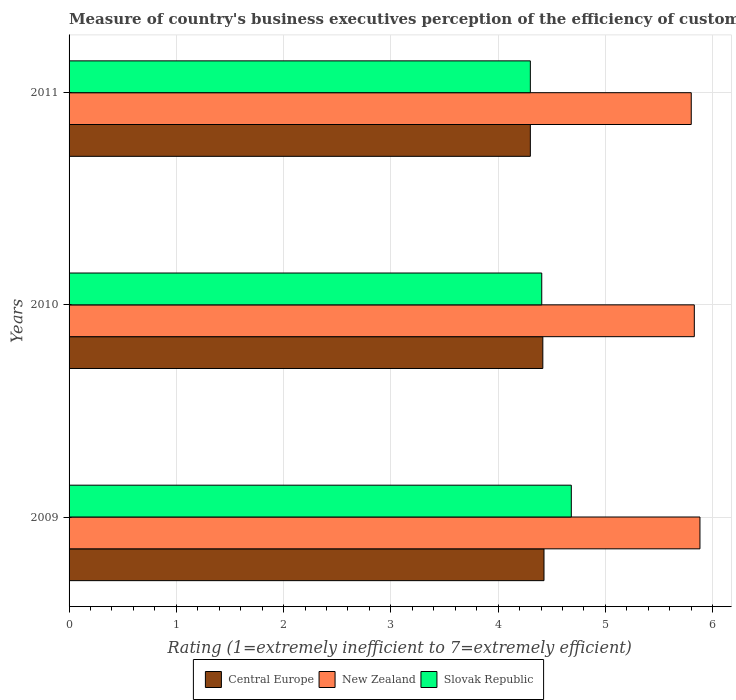How many groups of bars are there?
Give a very brief answer. 3. Are the number of bars per tick equal to the number of legend labels?
Your answer should be compact. Yes. Are the number of bars on each tick of the Y-axis equal?
Provide a succinct answer. Yes. How many bars are there on the 2nd tick from the top?
Your response must be concise. 3. How many bars are there on the 1st tick from the bottom?
Provide a short and direct response. 3. What is the label of the 1st group of bars from the top?
Ensure brevity in your answer.  2011. Across all years, what is the maximum rating of the efficiency of customs procedure in Slovak Republic?
Give a very brief answer. 4.68. In which year was the rating of the efficiency of customs procedure in Central Europe maximum?
Provide a short and direct response. 2009. In which year was the rating of the efficiency of customs procedure in New Zealand minimum?
Provide a succinct answer. 2011. What is the total rating of the efficiency of customs procedure in Slovak Republic in the graph?
Give a very brief answer. 13.39. What is the difference between the rating of the efficiency of customs procedure in New Zealand in 2010 and that in 2011?
Your response must be concise. 0.03. What is the difference between the rating of the efficiency of customs procedure in Central Europe in 2009 and the rating of the efficiency of customs procedure in Slovak Republic in 2011?
Provide a short and direct response. 0.13. What is the average rating of the efficiency of customs procedure in Slovak Republic per year?
Your response must be concise. 4.46. In the year 2011, what is the difference between the rating of the efficiency of customs procedure in New Zealand and rating of the efficiency of customs procedure in Central Europe?
Provide a succinct answer. 1.5. In how many years, is the rating of the efficiency of customs procedure in Slovak Republic greater than 5 ?
Your answer should be compact. 0. What is the ratio of the rating of the efficiency of customs procedure in Slovak Republic in 2010 to that in 2011?
Provide a succinct answer. 1.02. Is the rating of the efficiency of customs procedure in Central Europe in 2010 less than that in 2011?
Give a very brief answer. No. Is the difference between the rating of the efficiency of customs procedure in New Zealand in 2009 and 2011 greater than the difference between the rating of the efficiency of customs procedure in Central Europe in 2009 and 2011?
Give a very brief answer. No. What is the difference between the highest and the second highest rating of the efficiency of customs procedure in New Zealand?
Your response must be concise. 0.05. What is the difference between the highest and the lowest rating of the efficiency of customs procedure in Central Europe?
Make the answer very short. 0.13. Is the sum of the rating of the efficiency of customs procedure in Slovak Republic in 2010 and 2011 greater than the maximum rating of the efficiency of customs procedure in Central Europe across all years?
Make the answer very short. Yes. What does the 1st bar from the top in 2011 represents?
Keep it short and to the point. Slovak Republic. What does the 1st bar from the bottom in 2010 represents?
Provide a succinct answer. Central Europe. Is it the case that in every year, the sum of the rating of the efficiency of customs procedure in Central Europe and rating of the efficiency of customs procedure in Slovak Republic is greater than the rating of the efficiency of customs procedure in New Zealand?
Provide a succinct answer. Yes. Are all the bars in the graph horizontal?
Your answer should be compact. Yes. How many years are there in the graph?
Give a very brief answer. 3. Are the values on the major ticks of X-axis written in scientific E-notation?
Offer a terse response. No. Where does the legend appear in the graph?
Offer a very short reply. Bottom center. What is the title of the graph?
Offer a terse response. Measure of country's business executives perception of the efficiency of customs procedures. What is the label or title of the X-axis?
Ensure brevity in your answer.  Rating (1=extremely inefficient to 7=extremely efficient). What is the Rating (1=extremely inefficient to 7=extremely efficient) in Central Europe in 2009?
Your response must be concise. 4.43. What is the Rating (1=extremely inefficient to 7=extremely efficient) in New Zealand in 2009?
Provide a short and direct response. 5.88. What is the Rating (1=extremely inefficient to 7=extremely efficient) of Slovak Republic in 2009?
Provide a short and direct response. 4.68. What is the Rating (1=extremely inefficient to 7=extremely efficient) in Central Europe in 2010?
Your response must be concise. 4.42. What is the Rating (1=extremely inefficient to 7=extremely efficient) of New Zealand in 2010?
Your response must be concise. 5.83. What is the Rating (1=extremely inefficient to 7=extremely efficient) of Slovak Republic in 2010?
Make the answer very short. 4.41. What is the Rating (1=extremely inefficient to 7=extremely efficient) of Central Europe in 2011?
Your response must be concise. 4.3. What is the Rating (1=extremely inefficient to 7=extremely efficient) in New Zealand in 2011?
Your answer should be very brief. 5.8. Across all years, what is the maximum Rating (1=extremely inefficient to 7=extremely efficient) of Central Europe?
Your answer should be very brief. 4.43. Across all years, what is the maximum Rating (1=extremely inefficient to 7=extremely efficient) in New Zealand?
Offer a terse response. 5.88. Across all years, what is the maximum Rating (1=extremely inefficient to 7=extremely efficient) of Slovak Republic?
Provide a succinct answer. 4.68. Across all years, what is the minimum Rating (1=extremely inefficient to 7=extremely efficient) in Central Europe?
Offer a terse response. 4.3. Across all years, what is the minimum Rating (1=extremely inefficient to 7=extremely efficient) of New Zealand?
Make the answer very short. 5.8. Across all years, what is the minimum Rating (1=extremely inefficient to 7=extremely efficient) in Slovak Republic?
Keep it short and to the point. 4.3. What is the total Rating (1=extremely inefficient to 7=extremely efficient) of Central Europe in the graph?
Keep it short and to the point. 13.14. What is the total Rating (1=extremely inefficient to 7=extremely efficient) in New Zealand in the graph?
Your answer should be very brief. 17.51. What is the total Rating (1=extremely inefficient to 7=extremely efficient) of Slovak Republic in the graph?
Your answer should be compact. 13.39. What is the difference between the Rating (1=extremely inefficient to 7=extremely efficient) in Central Europe in 2009 and that in 2010?
Provide a short and direct response. 0.01. What is the difference between the Rating (1=extremely inefficient to 7=extremely efficient) in New Zealand in 2009 and that in 2010?
Your answer should be compact. 0.05. What is the difference between the Rating (1=extremely inefficient to 7=extremely efficient) in Slovak Republic in 2009 and that in 2010?
Your response must be concise. 0.28. What is the difference between the Rating (1=extremely inefficient to 7=extremely efficient) in Central Europe in 2009 and that in 2011?
Make the answer very short. 0.13. What is the difference between the Rating (1=extremely inefficient to 7=extremely efficient) of New Zealand in 2009 and that in 2011?
Keep it short and to the point. 0.08. What is the difference between the Rating (1=extremely inefficient to 7=extremely efficient) of Slovak Republic in 2009 and that in 2011?
Your response must be concise. 0.38. What is the difference between the Rating (1=extremely inefficient to 7=extremely efficient) of Central Europe in 2010 and that in 2011?
Give a very brief answer. 0.12. What is the difference between the Rating (1=extremely inefficient to 7=extremely efficient) in New Zealand in 2010 and that in 2011?
Make the answer very short. 0.03. What is the difference between the Rating (1=extremely inefficient to 7=extremely efficient) of Slovak Republic in 2010 and that in 2011?
Keep it short and to the point. 0.11. What is the difference between the Rating (1=extremely inefficient to 7=extremely efficient) of Central Europe in 2009 and the Rating (1=extremely inefficient to 7=extremely efficient) of New Zealand in 2010?
Keep it short and to the point. -1.4. What is the difference between the Rating (1=extremely inefficient to 7=extremely efficient) in Central Europe in 2009 and the Rating (1=extremely inefficient to 7=extremely efficient) in Slovak Republic in 2010?
Your answer should be very brief. 0.02. What is the difference between the Rating (1=extremely inefficient to 7=extremely efficient) in New Zealand in 2009 and the Rating (1=extremely inefficient to 7=extremely efficient) in Slovak Republic in 2010?
Provide a short and direct response. 1.47. What is the difference between the Rating (1=extremely inefficient to 7=extremely efficient) of Central Europe in 2009 and the Rating (1=extremely inefficient to 7=extremely efficient) of New Zealand in 2011?
Offer a terse response. -1.37. What is the difference between the Rating (1=extremely inefficient to 7=extremely efficient) in Central Europe in 2009 and the Rating (1=extremely inefficient to 7=extremely efficient) in Slovak Republic in 2011?
Provide a short and direct response. 0.13. What is the difference between the Rating (1=extremely inefficient to 7=extremely efficient) of New Zealand in 2009 and the Rating (1=extremely inefficient to 7=extremely efficient) of Slovak Republic in 2011?
Provide a short and direct response. 1.58. What is the difference between the Rating (1=extremely inefficient to 7=extremely efficient) in Central Europe in 2010 and the Rating (1=extremely inefficient to 7=extremely efficient) in New Zealand in 2011?
Provide a succinct answer. -1.38. What is the difference between the Rating (1=extremely inefficient to 7=extremely efficient) in Central Europe in 2010 and the Rating (1=extremely inefficient to 7=extremely efficient) in Slovak Republic in 2011?
Provide a short and direct response. 0.12. What is the difference between the Rating (1=extremely inefficient to 7=extremely efficient) of New Zealand in 2010 and the Rating (1=extremely inefficient to 7=extremely efficient) of Slovak Republic in 2011?
Your answer should be compact. 1.53. What is the average Rating (1=extremely inefficient to 7=extremely efficient) of Central Europe per year?
Your response must be concise. 4.38. What is the average Rating (1=extremely inefficient to 7=extremely efficient) of New Zealand per year?
Your answer should be very brief. 5.84. What is the average Rating (1=extremely inefficient to 7=extremely efficient) of Slovak Republic per year?
Your answer should be very brief. 4.46. In the year 2009, what is the difference between the Rating (1=extremely inefficient to 7=extremely efficient) of Central Europe and Rating (1=extremely inefficient to 7=extremely efficient) of New Zealand?
Give a very brief answer. -1.45. In the year 2009, what is the difference between the Rating (1=extremely inefficient to 7=extremely efficient) in Central Europe and Rating (1=extremely inefficient to 7=extremely efficient) in Slovak Republic?
Offer a very short reply. -0.25. In the year 2009, what is the difference between the Rating (1=extremely inefficient to 7=extremely efficient) in New Zealand and Rating (1=extremely inefficient to 7=extremely efficient) in Slovak Republic?
Ensure brevity in your answer.  1.2. In the year 2010, what is the difference between the Rating (1=extremely inefficient to 7=extremely efficient) in Central Europe and Rating (1=extremely inefficient to 7=extremely efficient) in New Zealand?
Your answer should be very brief. -1.41. In the year 2010, what is the difference between the Rating (1=extremely inefficient to 7=extremely efficient) of Central Europe and Rating (1=extremely inefficient to 7=extremely efficient) of Slovak Republic?
Make the answer very short. 0.01. In the year 2010, what is the difference between the Rating (1=extremely inefficient to 7=extremely efficient) in New Zealand and Rating (1=extremely inefficient to 7=extremely efficient) in Slovak Republic?
Provide a short and direct response. 1.42. In the year 2011, what is the difference between the Rating (1=extremely inefficient to 7=extremely efficient) of New Zealand and Rating (1=extremely inefficient to 7=extremely efficient) of Slovak Republic?
Ensure brevity in your answer.  1.5. What is the ratio of the Rating (1=extremely inefficient to 7=extremely efficient) in New Zealand in 2009 to that in 2010?
Provide a succinct answer. 1.01. What is the ratio of the Rating (1=extremely inefficient to 7=extremely efficient) of Central Europe in 2009 to that in 2011?
Provide a short and direct response. 1.03. What is the ratio of the Rating (1=extremely inefficient to 7=extremely efficient) in New Zealand in 2009 to that in 2011?
Make the answer very short. 1.01. What is the ratio of the Rating (1=extremely inefficient to 7=extremely efficient) in Slovak Republic in 2009 to that in 2011?
Give a very brief answer. 1.09. What is the ratio of the Rating (1=extremely inefficient to 7=extremely efficient) in Central Europe in 2010 to that in 2011?
Your answer should be compact. 1.03. What is the ratio of the Rating (1=extremely inefficient to 7=extremely efficient) of New Zealand in 2010 to that in 2011?
Provide a short and direct response. 1. What is the ratio of the Rating (1=extremely inefficient to 7=extremely efficient) of Slovak Republic in 2010 to that in 2011?
Offer a terse response. 1.02. What is the difference between the highest and the second highest Rating (1=extremely inefficient to 7=extremely efficient) of Central Europe?
Offer a terse response. 0.01. What is the difference between the highest and the second highest Rating (1=extremely inefficient to 7=extremely efficient) in New Zealand?
Your response must be concise. 0.05. What is the difference between the highest and the second highest Rating (1=extremely inefficient to 7=extremely efficient) in Slovak Republic?
Your response must be concise. 0.28. What is the difference between the highest and the lowest Rating (1=extremely inefficient to 7=extremely efficient) of Central Europe?
Keep it short and to the point. 0.13. What is the difference between the highest and the lowest Rating (1=extremely inefficient to 7=extremely efficient) in New Zealand?
Offer a terse response. 0.08. What is the difference between the highest and the lowest Rating (1=extremely inefficient to 7=extremely efficient) in Slovak Republic?
Offer a very short reply. 0.38. 